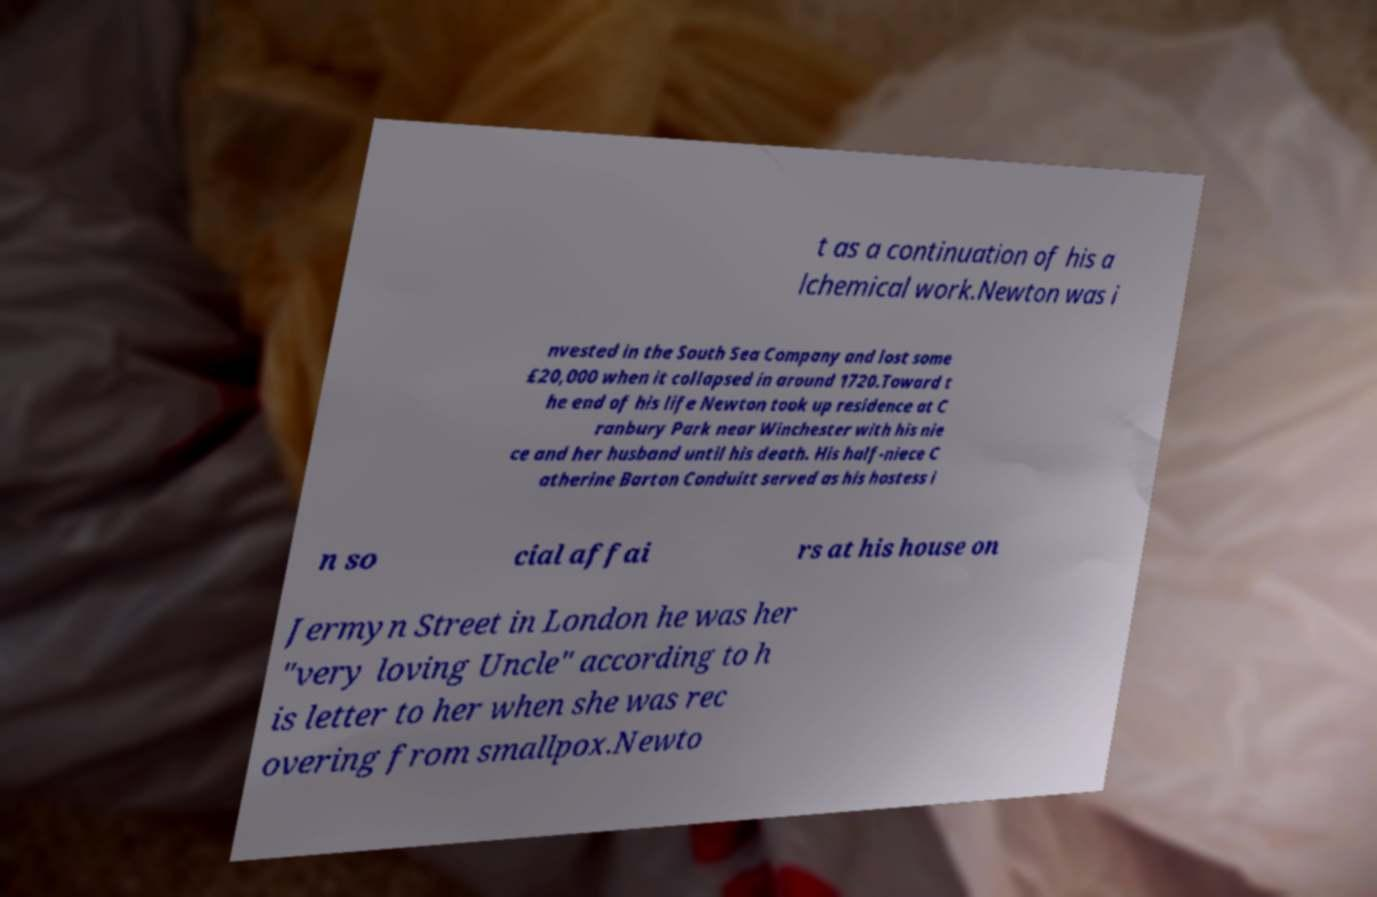What messages or text are displayed in this image? I need them in a readable, typed format. t as a continuation of his a lchemical work.Newton was i nvested in the South Sea Company and lost some £20,000 when it collapsed in around 1720.Toward t he end of his life Newton took up residence at C ranbury Park near Winchester with his nie ce and her husband until his death. His half-niece C atherine Barton Conduitt served as his hostess i n so cial affai rs at his house on Jermyn Street in London he was her "very loving Uncle" according to h is letter to her when she was rec overing from smallpox.Newto 